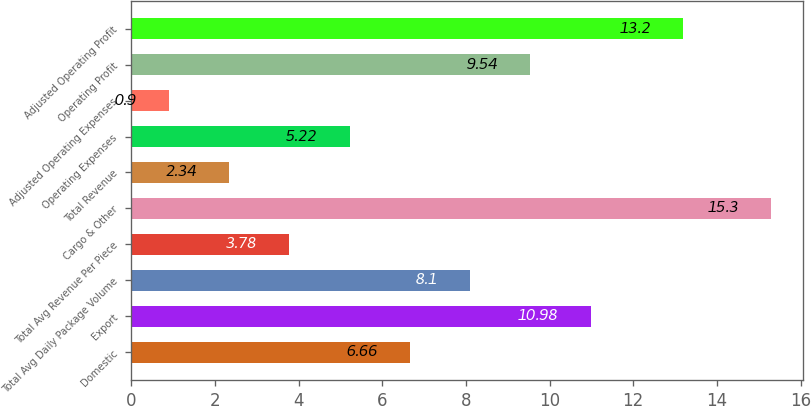<chart> <loc_0><loc_0><loc_500><loc_500><bar_chart><fcel>Domestic<fcel>Export<fcel>Total Avg Daily Package Volume<fcel>Total Avg Revenue Per Piece<fcel>Cargo & Other<fcel>Total Revenue<fcel>Operating Expenses<fcel>Adjusted Operating Expenses<fcel>Operating Profit<fcel>Adjusted Operating Profit<nl><fcel>6.66<fcel>10.98<fcel>8.1<fcel>3.78<fcel>15.3<fcel>2.34<fcel>5.22<fcel>0.9<fcel>9.54<fcel>13.2<nl></chart> 